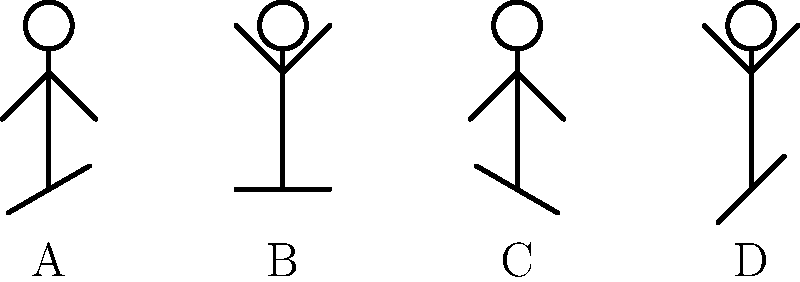Match the following sarcastic phrases with the most appropriate stick figure body language illustration:

1. "Oh, great. Another meeting that could've been an email."
2. "Wow, I'm so excited to work overtime this weekend!"
3. "Sure, I'd love to hear about your cat's dietary habits for the next hour."
4. "Fantastic! The printer is jammed again. Just what I needed today."

Which stick figure (A, B, C, or D) best represents the body language for each sarcastic phrase? To match sarcastic phrases with appropriate body language, we need to analyze the implied emotions and typical physical responses:

1. "Oh, great. Another meeting that could've been an email."
   This phrase expresses frustration and resignation. The most fitting posture would be slightly slumped shoulders and a tilted head, indicating weariness. Figure A best represents this.

2. "Wow, I'm so excited to work overtime this weekend!"
   This sarcastic statement implies the opposite of excitement. The most appropriate body language would be an exaggerated "excited" pose, mocking the idea of enthusiasm. Figure B, with raised arms, best portrays this mock excitement.

3. "Sure, I'd love to hear about your cat's dietary habits for the next hour."
   This phrase suggests boredom and lack of interest, masked as politeness. A slightly slouched posture with a tilted head, as shown in Figure C, best represents feigned interest and hidden impatience.

4. "Fantastic! The printer is jammed again. Just what I needed today."
   This sarcastic comment expresses frustration and exasperation. The most fitting body language would be raised arms, indicating a dramatic reaction to the situation. Figure D best illustrates this exaggerated response.

By analyzing the emotional subtext of each sarcastic phrase and matching it with the most appropriate physical representation, we can determine the best stick figure for each statement.
Answer: 1-A, 2-B, 3-C, 4-D 